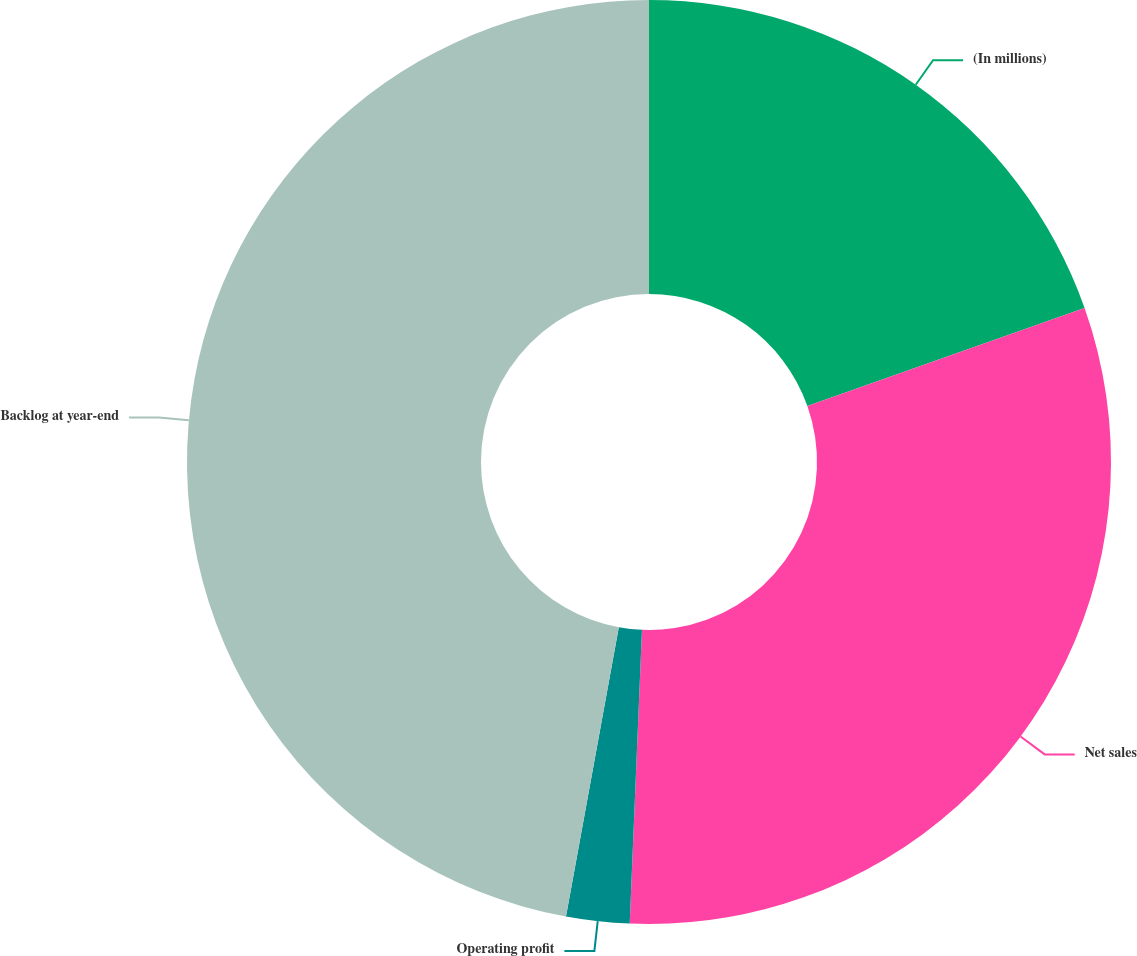Convert chart. <chart><loc_0><loc_0><loc_500><loc_500><pie_chart><fcel>(In millions)<fcel>Net sales<fcel>Operating profit<fcel>Backlog at year-end<nl><fcel>19.59%<fcel>31.07%<fcel>2.21%<fcel>47.12%<nl></chart> 